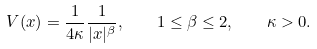<formula> <loc_0><loc_0><loc_500><loc_500>V ( x ) = \frac { 1 } { 4 \kappa } \frac { 1 } { | x | ^ { \beta } } , \quad 1 \leq \beta \leq 2 , \quad \kappa > 0 .</formula> 